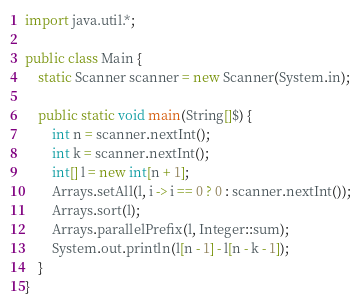<code> <loc_0><loc_0><loc_500><loc_500><_Java_>import java.util.*;

public class Main {
    static Scanner scanner = new Scanner(System.in);

    public static void main(String[]$) {
        int n = scanner.nextInt();
        int k = scanner.nextInt();
        int[] l = new int[n + 1];
        Arrays.setAll(l, i -> i == 0 ? 0 : scanner.nextInt());
        Arrays.sort(l);
        Arrays.parallelPrefix(l, Integer::sum);
        System.out.println(l[n - 1] - l[n - k - 1]);
    }
}</code> 